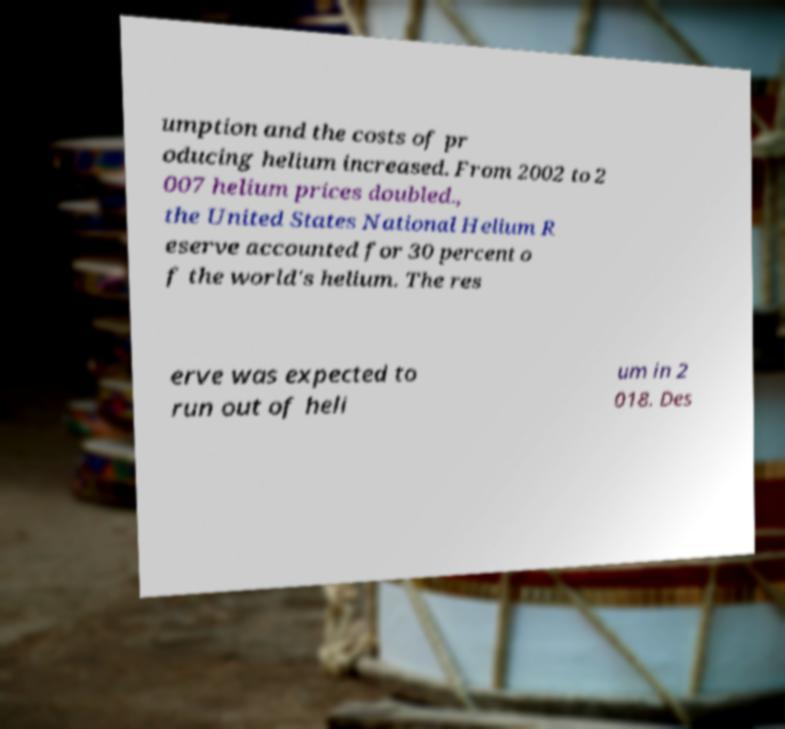Please read and relay the text visible in this image. What does it say? umption and the costs of pr oducing helium increased. From 2002 to 2 007 helium prices doubled., the United States National Helium R eserve accounted for 30 percent o f the world's helium. The res erve was expected to run out of heli um in 2 018. Des 